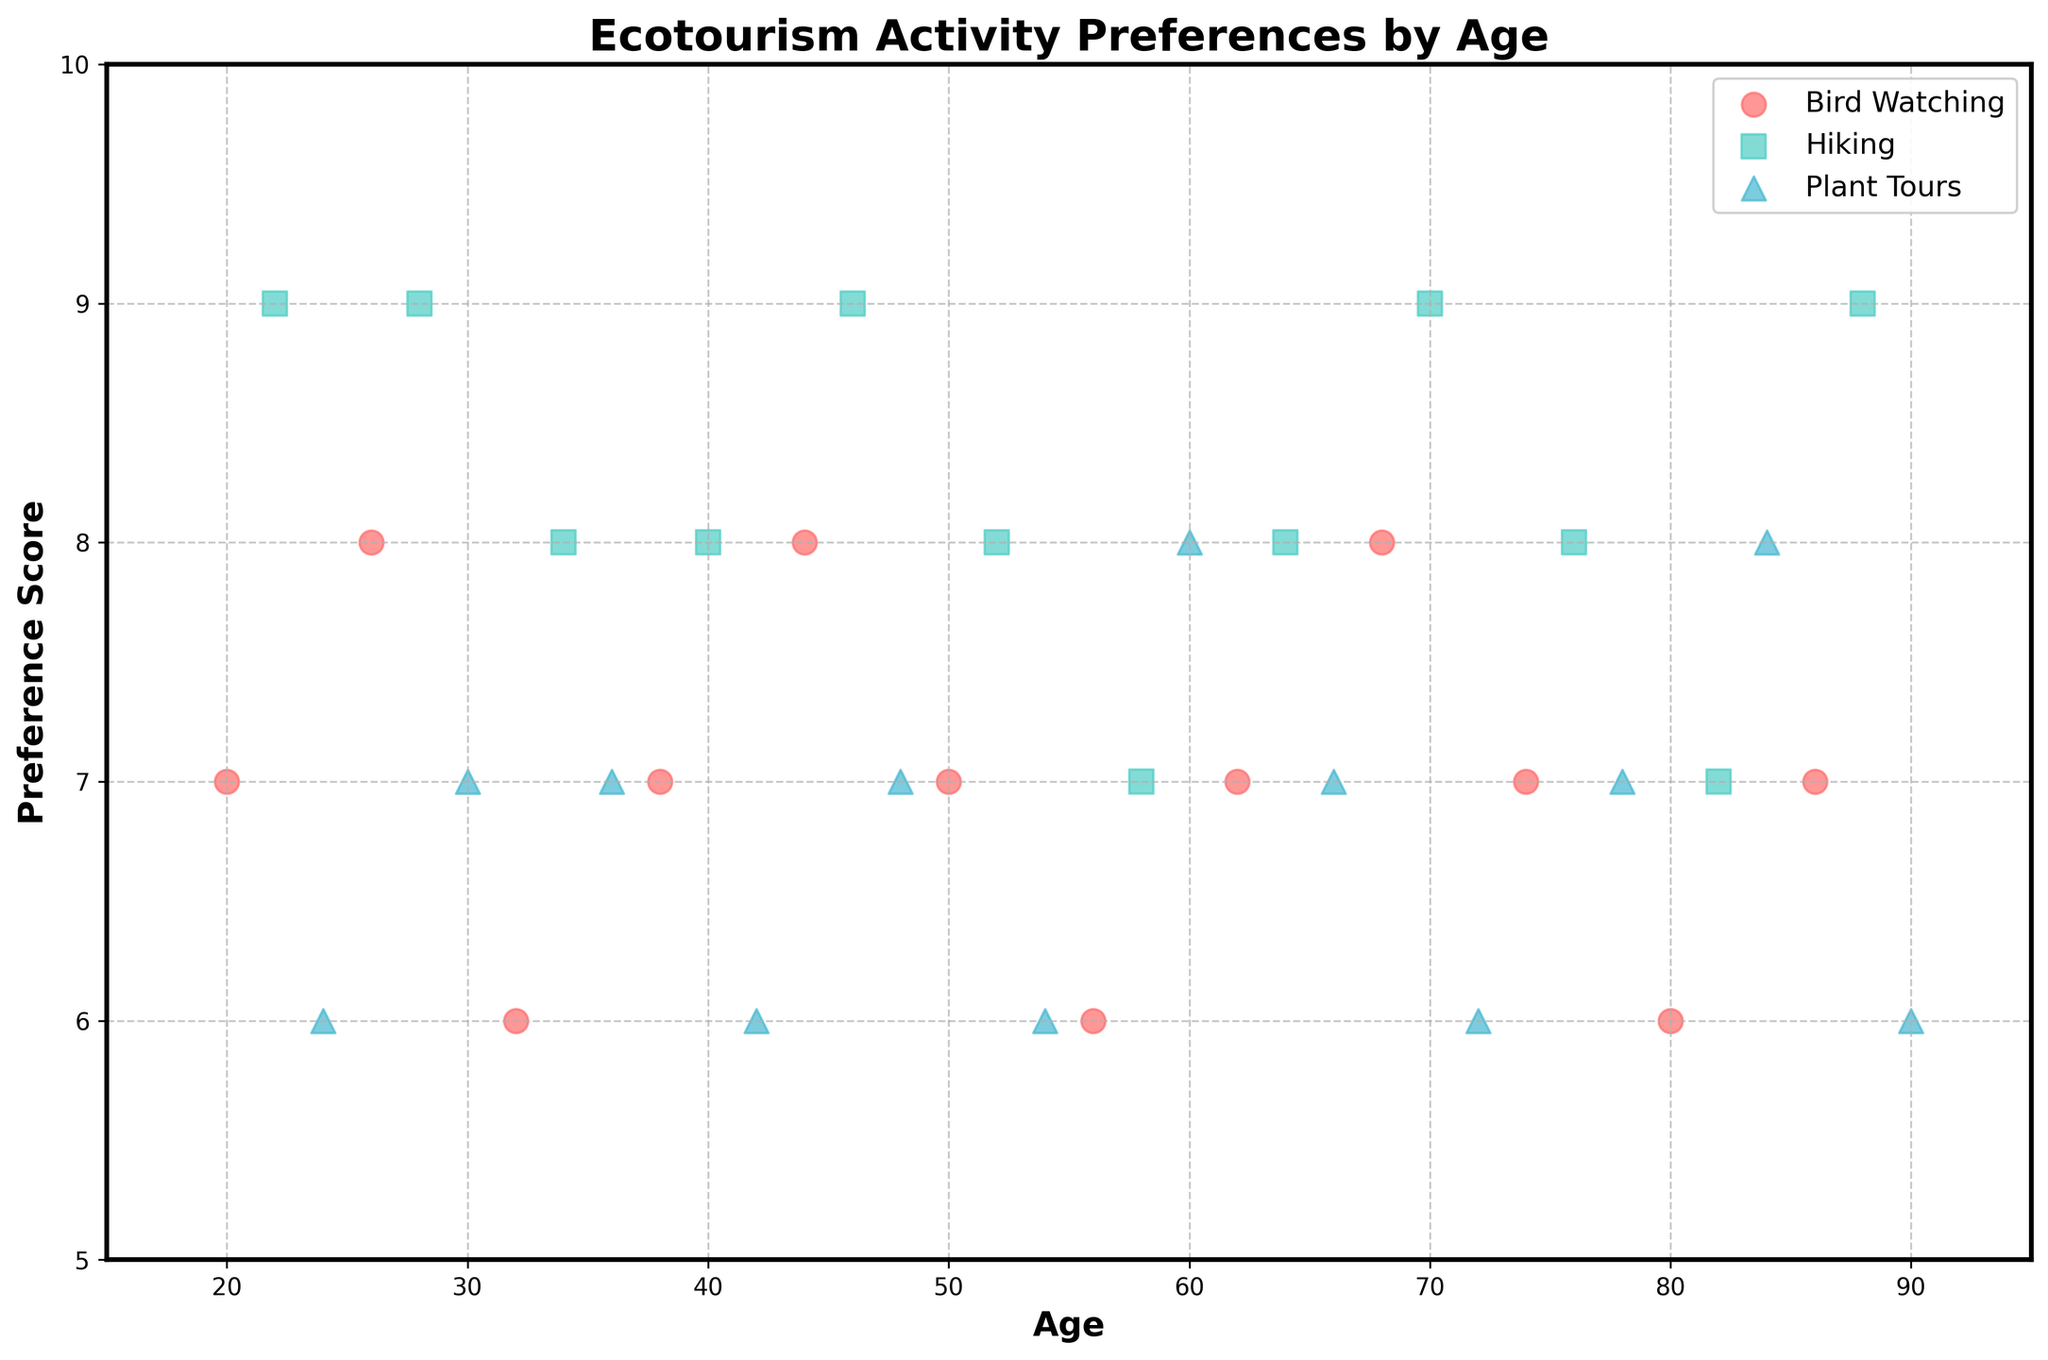What's the title of the plot? The title of the plot is usually positioned at the top of the figure and can be easily read.
Answer: Ecotourism Activity Preferences by Age What are the activities represented in the plot? The legend at the top right corner of the plot shows the different groups represented.
Answer: Bird Watching, Hiking, Plant Tours Which activity has the highest preference score? By observing the y-axis and the data points, we can see that Hiking has the preference scores reaching up to 9 whereas other activities do not exceed this score.
Answer: Hiking How many data points are there for Bird Watching? We count the number of scatter points (red circles) representing Bird Watching from the plot.
Answer: 13 What is the average preference score for Plant Tours? Identify the y-values of all the Plant Tours (blue triangles) and calculate their average: (6+7+7+6+7+7+6+8+7+6+8+6)/12.
Answer: 6.75 Which age group shows the highest preference for Hiking? Find the data point for Hiking (green squares) with the highest y-value, which corresponds to age 22 and 70. Both have preference scores of 9.
Answer: 22 and 70 Between ages 50 and 60, which activity has the most points and what is it? Count the data points in the age range 50-60 for each activity. Plant Tours has 1 point, Hiking has 2 points, and Bird Watching has 1 point. Hence, Hiking has the most points.
Answer: Hiking What is the preference score range for Bird Watching across all ages? Determine the minimum and maximum y-values for Bird Watching (red circles). The scores range from 6 to 8.
Answer: 6 to 8 Do preferences for any activity appear to increase or decrease with age? By analyzing the scatter points' distribution across ages, we notice that there is no clear trend of increasing or decreasing preference scores for any activities as age increases.
Answer: No clear trend 